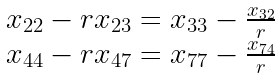<formula> <loc_0><loc_0><loc_500><loc_500>\begin{array} { l } x _ { 2 2 } - r x _ { 2 3 } = x _ { 3 3 } - \frac { x _ { 3 2 } } { r } \\ x _ { 4 4 } - r x _ { 4 7 } = x _ { 7 7 } - \frac { x _ { 7 4 } } { r } \end{array}</formula> 